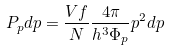Convert formula to latex. <formula><loc_0><loc_0><loc_500><loc_500>P _ { p } d p = { \frac { V f } { N } } { \frac { 4 \pi } { h ^ { 3 } \Phi _ { p } } } p ^ { 2 } d p</formula> 